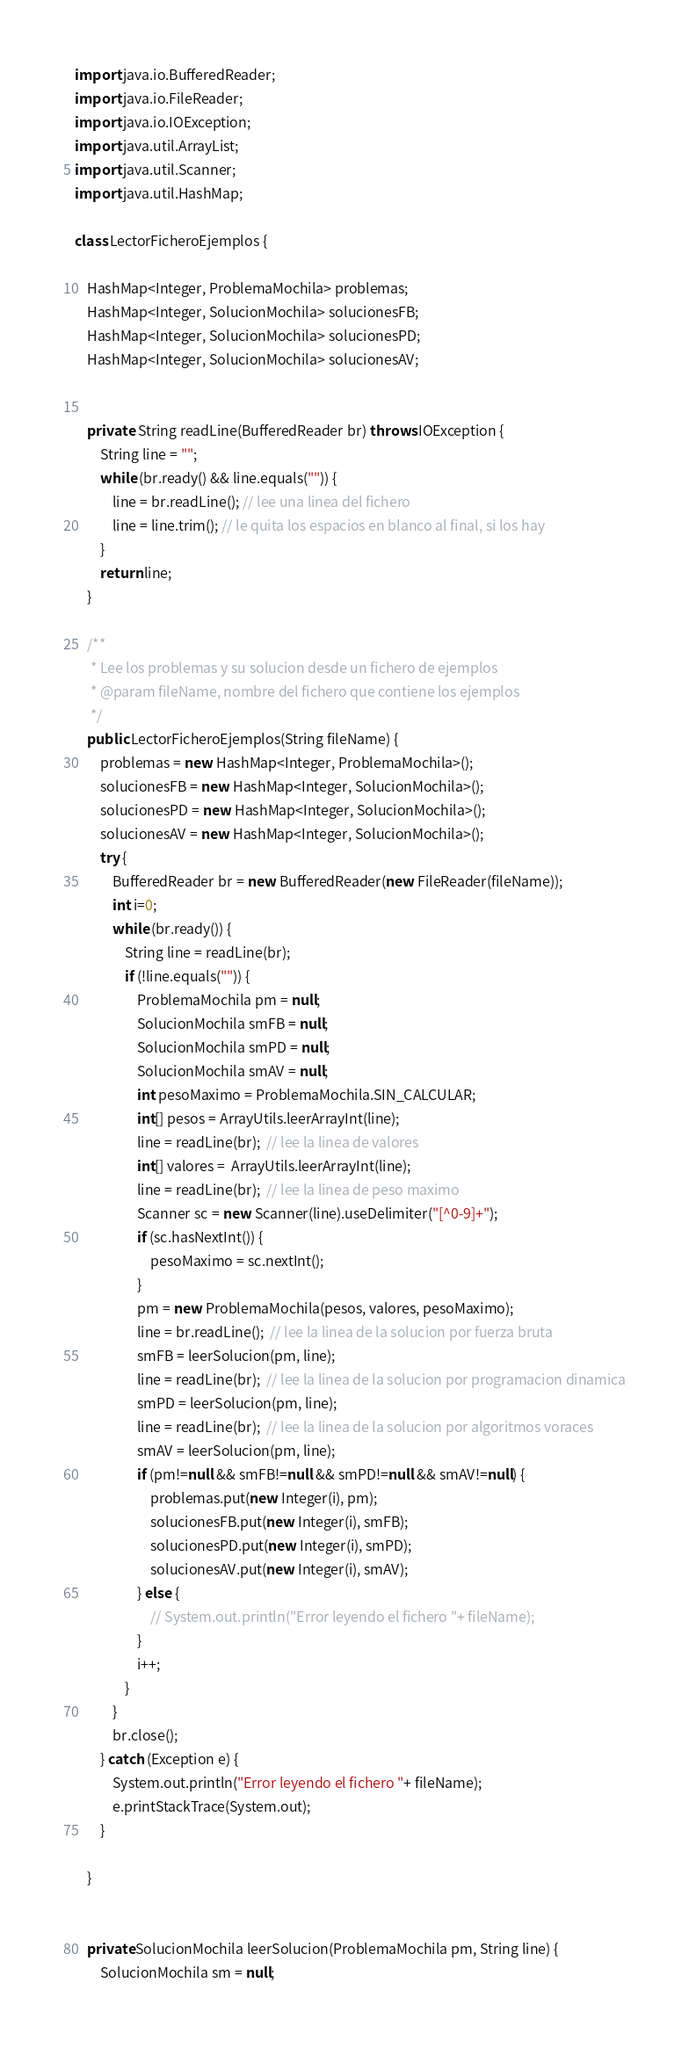Convert code to text. <code><loc_0><loc_0><loc_500><loc_500><_Java_>import java.io.BufferedReader;
import java.io.FileReader;
import java.io.IOException;
import java.util.ArrayList;
import java.util.Scanner;
import java.util.HashMap;

class LectorFicheroEjemplos {
	
	HashMap<Integer, ProblemaMochila> problemas;
	HashMap<Integer, SolucionMochila> solucionesFB;
	HashMap<Integer, SolucionMochila> solucionesPD;
	HashMap<Integer, SolucionMochila> solucionesAV;
	
	
	private  String readLine(BufferedReader br) throws IOException {
		String line = "";
		while (br.ready() && line.equals("")) {
			line = br.readLine(); // lee una linea del fichero
			line = line.trim(); // le quita los espacios en blanco al final, si los hay
		}
		return line;
	}
	
	/**
	 * Lee los problemas y su solucion desde un fichero de ejemplos  
	 * @param fileName, nombre del fichero que contiene los ejemplos
	 */
	public LectorFicheroEjemplos(String fileName) {
		problemas = new HashMap<Integer, ProblemaMochila>();
		solucionesFB = new HashMap<Integer, SolucionMochila>();
		solucionesPD = new HashMap<Integer, SolucionMochila>();
		solucionesAV = new HashMap<Integer, SolucionMochila>();
		try {
			BufferedReader br = new BufferedReader(new FileReader(fileName));
			int i=0;
			while (br.ready()) {
				String line = readLine(br);
				if (!line.equals("")) {
					ProblemaMochila pm = null;
					SolucionMochila smFB = null;
					SolucionMochila smPD = null;
					SolucionMochila smAV = null;
					int pesoMaximo = ProblemaMochila.SIN_CALCULAR;
					int[] pesos = ArrayUtils.leerArrayInt(line);
					line = readLine(br);  // lee la linea de valores
					int[] valores =  ArrayUtils.leerArrayInt(line); 
					line = readLine(br);  // lee la linea de peso maximo
					Scanner sc = new Scanner(line).useDelimiter("[^0-9]+");
					if (sc.hasNextInt()) {
						pesoMaximo = sc.nextInt();
					}
					pm = new ProblemaMochila(pesos, valores, pesoMaximo);
					line = br.readLine();  // lee la linea de la solucion por fuerza bruta
					smFB = leerSolucion(pm, line);							
					line = readLine(br);  // lee la linea de la solucion por programacion dinamica
					smPD = leerSolucion(pm, line);							
					line = readLine(br);  // lee la linea de la solucion por algoritmos voraces
					smAV = leerSolucion(pm, line);							
					if (pm!=null && smFB!=null && smPD!=null && smAV!=null) {
					    problemas.put(new Integer(i), pm);
					    solucionesFB.put(new Integer(i), smFB);
					    solucionesPD.put(new Integer(i), smPD);
					    solucionesAV.put(new Integer(i), smAV);
					} else {
						// System.out.println("Error leyendo el fichero "+ fileName);
					}
					i++;
				}
			}
			br.close();
		} catch (Exception e) {
			System.out.println("Error leyendo el fichero "+ fileName);
			e.printStackTrace(System.out);
		}
		
	}


	private SolucionMochila leerSolucion(ProblemaMochila pm, String line) {
		SolucionMochila sm = null;</code> 